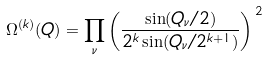Convert formula to latex. <formula><loc_0><loc_0><loc_500><loc_500>\Omega ^ { ( k ) } ( Q ) = \prod _ { \nu } \left ( \frac { \sin ( Q _ { \nu } / 2 ) } { 2 ^ { k } \sin ( Q _ { \nu } / 2 ^ { k + 1 } ) } \right ) ^ { \, 2 }</formula> 